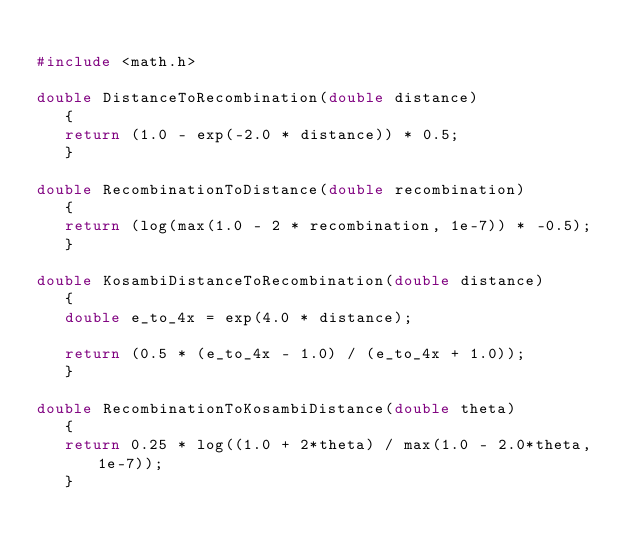<code> <loc_0><loc_0><loc_500><loc_500><_C++_>
#include <math.h>

double DistanceToRecombination(double distance)
   {
   return (1.0 - exp(-2.0 * distance)) * 0.5;
   }

double RecombinationToDistance(double recombination)
   {
   return (log(max(1.0 - 2 * recombination, 1e-7)) * -0.5);
   }

double KosambiDistanceToRecombination(double distance)
   {
   double e_to_4x = exp(4.0 * distance);

   return (0.5 * (e_to_4x - 1.0) / (e_to_4x + 1.0));
   }

double RecombinationToKosambiDistance(double theta)
   {
   return 0.25 * log((1.0 + 2*theta) / max(1.0 - 2.0*theta, 1e-7));
   }
</code> 